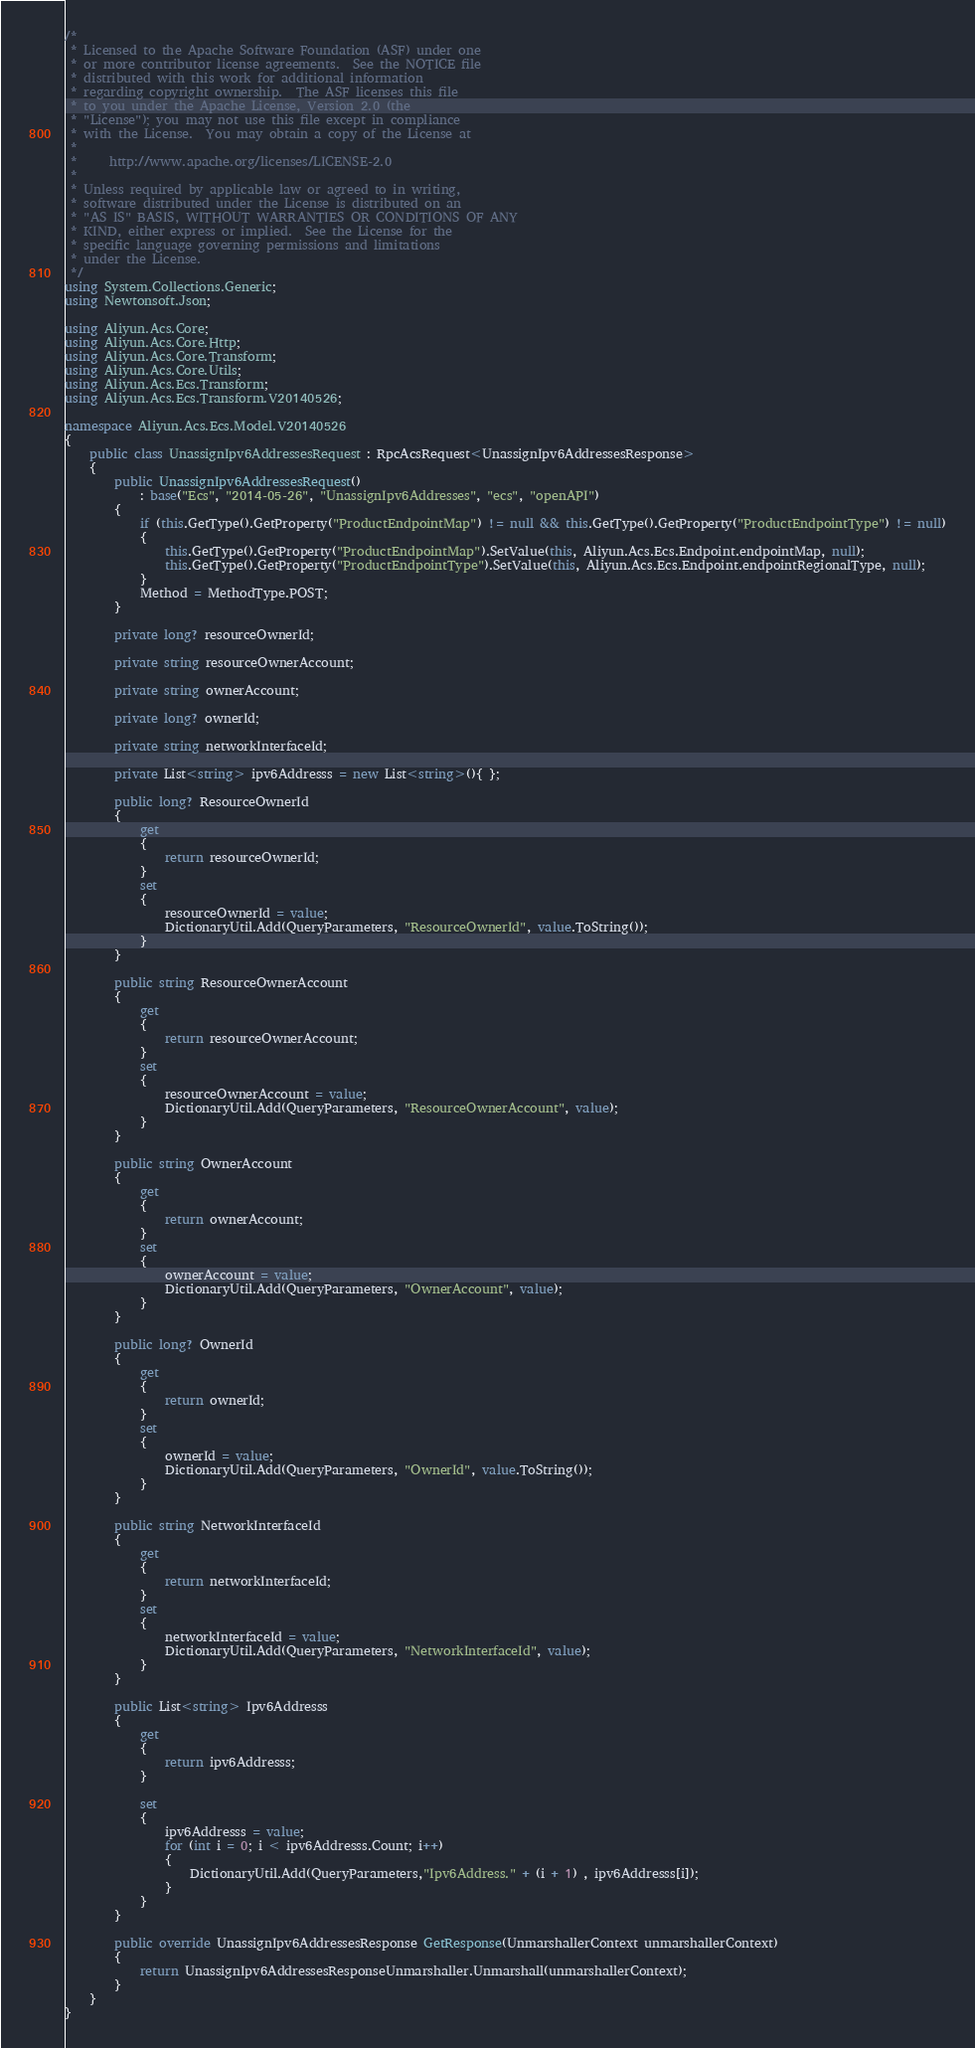<code> <loc_0><loc_0><loc_500><loc_500><_C#_>/*
 * Licensed to the Apache Software Foundation (ASF) under one
 * or more contributor license agreements.  See the NOTICE file
 * distributed with this work for additional information
 * regarding copyright ownership.  The ASF licenses this file
 * to you under the Apache License, Version 2.0 (the
 * "License"); you may not use this file except in compliance
 * with the License.  You may obtain a copy of the License at
 *
 *     http://www.apache.org/licenses/LICENSE-2.0
 *
 * Unless required by applicable law or agreed to in writing,
 * software distributed under the License is distributed on an
 * "AS IS" BASIS, WITHOUT WARRANTIES OR CONDITIONS OF ANY
 * KIND, either express or implied.  See the License for the
 * specific language governing permissions and limitations
 * under the License.
 */
using System.Collections.Generic;
using Newtonsoft.Json;

using Aliyun.Acs.Core;
using Aliyun.Acs.Core.Http;
using Aliyun.Acs.Core.Transform;
using Aliyun.Acs.Core.Utils;
using Aliyun.Acs.Ecs.Transform;
using Aliyun.Acs.Ecs.Transform.V20140526;

namespace Aliyun.Acs.Ecs.Model.V20140526
{
    public class UnassignIpv6AddressesRequest : RpcAcsRequest<UnassignIpv6AddressesResponse>
    {
        public UnassignIpv6AddressesRequest()
            : base("Ecs", "2014-05-26", "UnassignIpv6Addresses", "ecs", "openAPI")
        {
            if (this.GetType().GetProperty("ProductEndpointMap") != null && this.GetType().GetProperty("ProductEndpointType") != null)
            {
                this.GetType().GetProperty("ProductEndpointMap").SetValue(this, Aliyun.Acs.Ecs.Endpoint.endpointMap, null);
                this.GetType().GetProperty("ProductEndpointType").SetValue(this, Aliyun.Acs.Ecs.Endpoint.endpointRegionalType, null);
            }
			Method = MethodType.POST;
        }

		private long? resourceOwnerId;

		private string resourceOwnerAccount;

		private string ownerAccount;

		private long? ownerId;

		private string networkInterfaceId;

		private List<string> ipv6Addresss = new List<string>(){ };

		public long? ResourceOwnerId
		{
			get
			{
				return resourceOwnerId;
			}
			set	
			{
				resourceOwnerId = value;
				DictionaryUtil.Add(QueryParameters, "ResourceOwnerId", value.ToString());
			}
		}

		public string ResourceOwnerAccount
		{
			get
			{
				return resourceOwnerAccount;
			}
			set	
			{
				resourceOwnerAccount = value;
				DictionaryUtil.Add(QueryParameters, "ResourceOwnerAccount", value);
			}
		}

		public string OwnerAccount
		{
			get
			{
				return ownerAccount;
			}
			set	
			{
				ownerAccount = value;
				DictionaryUtil.Add(QueryParameters, "OwnerAccount", value);
			}
		}

		public long? OwnerId
		{
			get
			{
				return ownerId;
			}
			set	
			{
				ownerId = value;
				DictionaryUtil.Add(QueryParameters, "OwnerId", value.ToString());
			}
		}

		public string NetworkInterfaceId
		{
			get
			{
				return networkInterfaceId;
			}
			set	
			{
				networkInterfaceId = value;
				DictionaryUtil.Add(QueryParameters, "NetworkInterfaceId", value);
			}
		}

		public List<string> Ipv6Addresss
		{
			get
			{
				return ipv6Addresss;
			}

			set
			{
				ipv6Addresss = value;
				for (int i = 0; i < ipv6Addresss.Count; i++)
				{
					DictionaryUtil.Add(QueryParameters,"Ipv6Address." + (i + 1) , ipv6Addresss[i]);
				}
			}
		}

        public override UnassignIpv6AddressesResponse GetResponse(UnmarshallerContext unmarshallerContext)
        {
            return UnassignIpv6AddressesResponseUnmarshaller.Unmarshall(unmarshallerContext);
        }
    }
}
</code> 